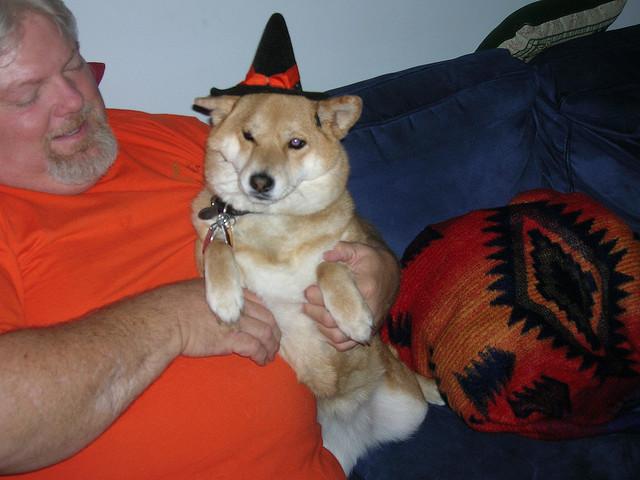Why would this relationship normally be unusual?
Quick response, please. No idea. Is the dog happy?
Be succinct. Yes. Is the dog angry?
Answer briefly. No. What type of hat is the dog wearing?
Answer briefly. Witch. How many animals are in this pick?
Be succinct. 1. What is the dog wrapped up in?
Short answer required. Nothing. Is the dog male or female?
Keep it brief. Male. What is the man holding up?
Keep it brief. Dog. What holiday is this person celebrating?
Answer briefly. Halloween. What breed of dog is this?
Answer briefly. Corgi. What color is the dog's hat?
Give a very brief answer. Black. Is the dog a mutt?
Give a very brief answer. No. Which holiday do these animals evoke?
Short answer required. Halloween. Is this dog alone in this photo?
Write a very short answer. No. What does this dog want?
Answer briefly. Sleep. Is the dog sitting in a natural and comfortable position?
Write a very short answer. No. Does the pair look happy together?
Keep it brief. Yes. What color is the dog?
Short answer required. Tan. What is the dog sitting on?
Give a very brief answer. Couch. What does the collar say?
Be succinct. Nothing. 